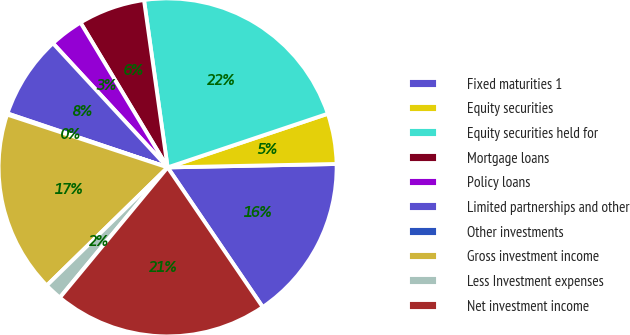<chart> <loc_0><loc_0><loc_500><loc_500><pie_chart><fcel>Fixed maturities 1<fcel>Equity securities<fcel>Equity securities held for<fcel>Mortgage loans<fcel>Policy loans<fcel>Limited partnerships and other<fcel>Other investments<fcel>Gross investment income<fcel>Less Investment expenses<fcel>Net investment income<nl><fcel>15.81%<fcel>4.82%<fcel>22.09%<fcel>6.39%<fcel>3.25%<fcel>7.96%<fcel>0.11%<fcel>17.38%<fcel>1.68%<fcel>20.52%<nl></chart> 